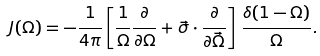Convert formula to latex. <formula><loc_0><loc_0><loc_500><loc_500>J ( \Omega ) = - \frac { 1 } { 4 \pi } \left [ \frac { 1 } { \Omega } \frac { \partial } { \partial \Omega } + \vec { \sigma } \cdot \frac { \partial } { \partial \vec { \Omega } } \right ] \, \frac { \delta ( 1 - \Omega ) } { \Omega } .</formula> 